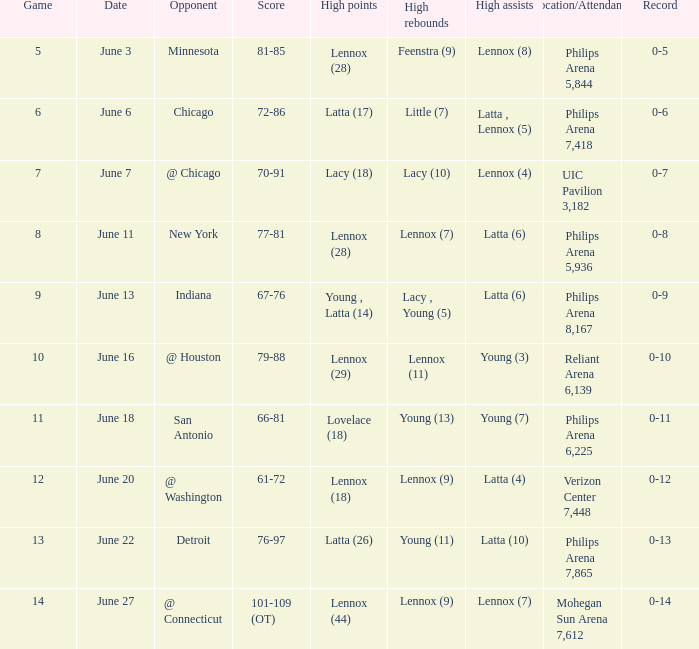In which stadium was the june 7 event held, and what was the attendance count? UIC Pavilion 3,182. 